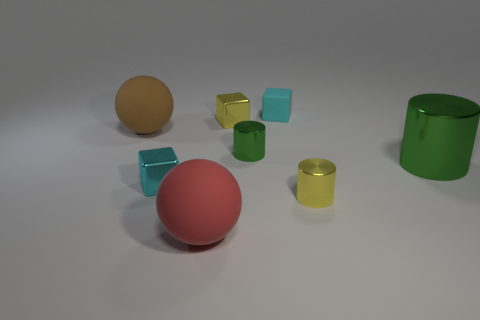Subtract all tiny metallic cubes. How many cubes are left? 1 Subtract all red spheres. How many spheres are left? 1 Subtract 1 balls. How many balls are left? 1 Add 1 shiny cylinders. How many objects exist? 9 Subtract all blue cubes. Subtract all green spheres. How many cubes are left? 3 Add 5 large blue rubber cylinders. How many large blue rubber cylinders exist? 5 Subtract 0 purple balls. How many objects are left? 8 Subtract all cubes. How many objects are left? 5 Subtract all blue blocks. How many brown spheres are left? 1 Subtract all big green matte spheres. Subtract all yellow metal objects. How many objects are left? 6 